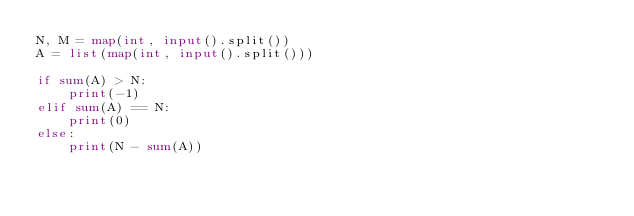<code> <loc_0><loc_0><loc_500><loc_500><_Python_>N, M = map(int, input().split())
A = list(map(int, input().split()))

if sum(A) > N:
    print(-1)
elif sum(A) == N:
    print(0)
else:
    print(N - sum(A))
</code> 